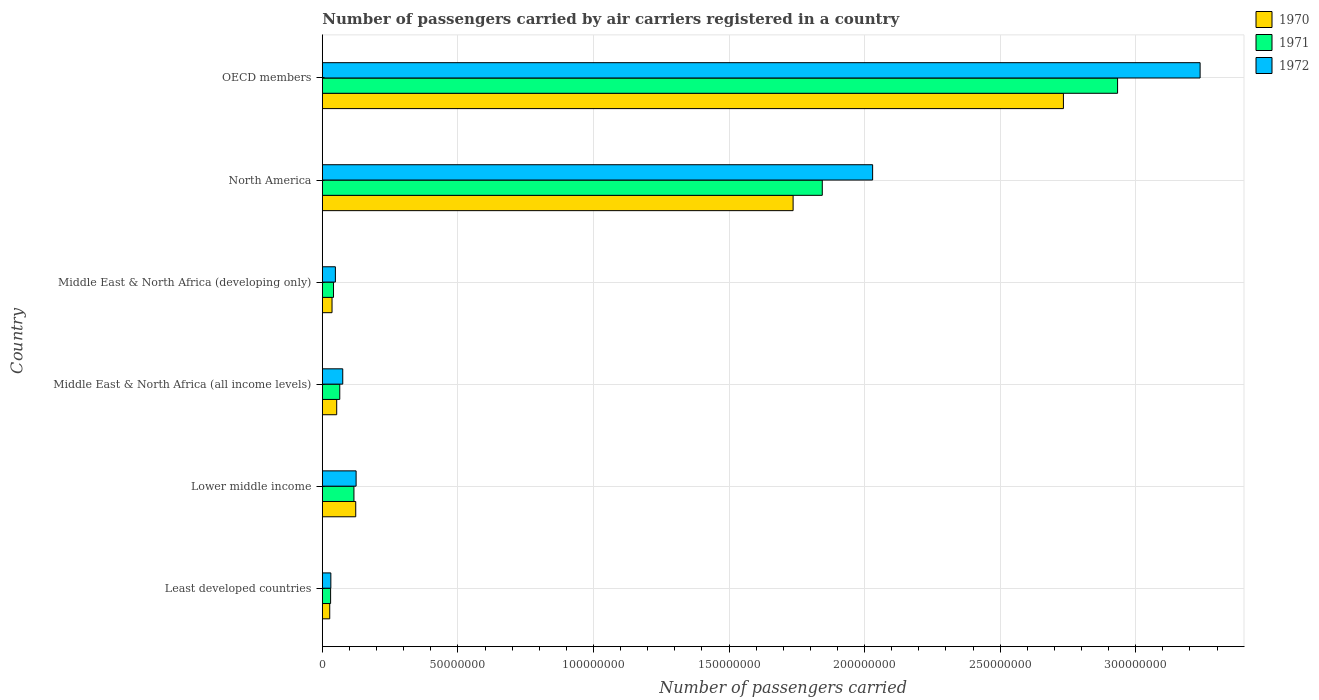How many different coloured bars are there?
Offer a very short reply. 3. Are the number of bars per tick equal to the number of legend labels?
Offer a terse response. Yes. What is the label of the 3rd group of bars from the top?
Make the answer very short. Middle East & North Africa (developing only). In how many cases, is the number of bars for a given country not equal to the number of legend labels?
Keep it short and to the point. 0. What is the number of passengers carried by air carriers in 1971 in Middle East & North Africa (all income levels)?
Your response must be concise. 6.43e+06. Across all countries, what is the maximum number of passengers carried by air carriers in 1971?
Provide a succinct answer. 2.93e+08. Across all countries, what is the minimum number of passengers carried by air carriers in 1970?
Your answer should be compact. 2.73e+06. In which country was the number of passengers carried by air carriers in 1972 minimum?
Your response must be concise. Least developed countries. What is the total number of passengers carried by air carriers in 1972 in the graph?
Your answer should be compact. 5.55e+08. What is the difference between the number of passengers carried by air carriers in 1970 in Middle East & North Africa (developing only) and that in North America?
Make the answer very short. -1.70e+08. What is the difference between the number of passengers carried by air carriers in 1972 in North America and the number of passengers carried by air carriers in 1970 in Middle East & North Africa (developing only)?
Provide a succinct answer. 1.99e+08. What is the average number of passengers carried by air carriers in 1970 per country?
Your answer should be very brief. 7.85e+07. What is the difference between the number of passengers carried by air carriers in 1971 and number of passengers carried by air carriers in 1972 in OECD members?
Your response must be concise. -3.04e+07. What is the ratio of the number of passengers carried by air carriers in 1971 in Middle East & North Africa (developing only) to that in North America?
Your response must be concise. 0.02. Is the difference between the number of passengers carried by air carriers in 1971 in Least developed countries and OECD members greater than the difference between the number of passengers carried by air carriers in 1972 in Least developed countries and OECD members?
Provide a succinct answer. Yes. What is the difference between the highest and the second highest number of passengers carried by air carriers in 1970?
Offer a very short reply. 9.97e+07. What is the difference between the highest and the lowest number of passengers carried by air carriers in 1972?
Give a very brief answer. 3.21e+08. In how many countries, is the number of passengers carried by air carriers in 1970 greater than the average number of passengers carried by air carriers in 1970 taken over all countries?
Provide a succinct answer. 2. What does the 2nd bar from the top in North America represents?
Offer a very short reply. 1971. What does the 1st bar from the bottom in OECD members represents?
Provide a short and direct response. 1970. Is it the case that in every country, the sum of the number of passengers carried by air carriers in 1972 and number of passengers carried by air carriers in 1970 is greater than the number of passengers carried by air carriers in 1971?
Make the answer very short. Yes. Are all the bars in the graph horizontal?
Your answer should be very brief. Yes. What is the difference between two consecutive major ticks on the X-axis?
Your answer should be very brief. 5.00e+07. Where does the legend appear in the graph?
Keep it short and to the point. Top right. How are the legend labels stacked?
Give a very brief answer. Vertical. What is the title of the graph?
Ensure brevity in your answer.  Number of passengers carried by air carriers registered in a country. Does "1986" appear as one of the legend labels in the graph?
Offer a very short reply. No. What is the label or title of the X-axis?
Your response must be concise. Number of passengers carried. What is the Number of passengers carried of 1970 in Least developed countries?
Make the answer very short. 2.73e+06. What is the Number of passengers carried in 1971 in Least developed countries?
Ensure brevity in your answer.  3.05e+06. What is the Number of passengers carried of 1972 in Least developed countries?
Provide a short and direct response. 3.14e+06. What is the Number of passengers carried in 1970 in Lower middle income?
Make the answer very short. 1.23e+07. What is the Number of passengers carried in 1971 in Lower middle income?
Your response must be concise. 1.17e+07. What is the Number of passengers carried in 1972 in Lower middle income?
Make the answer very short. 1.25e+07. What is the Number of passengers carried in 1970 in Middle East & North Africa (all income levels)?
Offer a very short reply. 5.30e+06. What is the Number of passengers carried of 1971 in Middle East & North Africa (all income levels)?
Your answer should be compact. 6.43e+06. What is the Number of passengers carried of 1972 in Middle East & North Africa (all income levels)?
Your answer should be compact. 7.53e+06. What is the Number of passengers carried in 1970 in Middle East & North Africa (developing only)?
Your answer should be very brief. 3.58e+06. What is the Number of passengers carried of 1971 in Middle East & North Africa (developing only)?
Offer a terse response. 4.12e+06. What is the Number of passengers carried in 1972 in Middle East & North Africa (developing only)?
Provide a succinct answer. 4.82e+06. What is the Number of passengers carried in 1970 in North America?
Provide a short and direct response. 1.74e+08. What is the Number of passengers carried in 1971 in North America?
Your answer should be compact. 1.84e+08. What is the Number of passengers carried in 1972 in North America?
Your answer should be compact. 2.03e+08. What is the Number of passengers carried of 1970 in OECD members?
Your answer should be very brief. 2.73e+08. What is the Number of passengers carried in 1971 in OECD members?
Ensure brevity in your answer.  2.93e+08. What is the Number of passengers carried in 1972 in OECD members?
Provide a succinct answer. 3.24e+08. Across all countries, what is the maximum Number of passengers carried of 1970?
Your response must be concise. 2.73e+08. Across all countries, what is the maximum Number of passengers carried in 1971?
Provide a short and direct response. 2.93e+08. Across all countries, what is the maximum Number of passengers carried in 1972?
Offer a terse response. 3.24e+08. Across all countries, what is the minimum Number of passengers carried of 1970?
Provide a short and direct response. 2.73e+06. Across all countries, what is the minimum Number of passengers carried in 1971?
Ensure brevity in your answer.  3.05e+06. Across all countries, what is the minimum Number of passengers carried of 1972?
Ensure brevity in your answer.  3.14e+06. What is the total Number of passengers carried of 1970 in the graph?
Provide a short and direct response. 4.71e+08. What is the total Number of passengers carried of 1971 in the graph?
Give a very brief answer. 5.03e+08. What is the total Number of passengers carried in 1972 in the graph?
Your response must be concise. 5.55e+08. What is the difference between the Number of passengers carried of 1970 in Least developed countries and that in Lower middle income?
Ensure brevity in your answer.  -9.59e+06. What is the difference between the Number of passengers carried in 1971 in Least developed countries and that in Lower middle income?
Your answer should be very brief. -8.60e+06. What is the difference between the Number of passengers carried of 1972 in Least developed countries and that in Lower middle income?
Provide a succinct answer. -9.32e+06. What is the difference between the Number of passengers carried in 1970 in Least developed countries and that in Middle East & North Africa (all income levels)?
Provide a short and direct response. -2.57e+06. What is the difference between the Number of passengers carried of 1971 in Least developed countries and that in Middle East & North Africa (all income levels)?
Give a very brief answer. -3.37e+06. What is the difference between the Number of passengers carried in 1972 in Least developed countries and that in Middle East & North Africa (all income levels)?
Ensure brevity in your answer.  -4.39e+06. What is the difference between the Number of passengers carried of 1970 in Least developed countries and that in Middle East & North Africa (developing only)?
Offer a very short reply. -8.45e+05. What is the difference between the Number of passengers carried of 1971 in Least developed countries and that in Middle East & North Africa (developing only)?
Give a very brief answer. -1.07e+06. What is the difference between the Number of passengers carried of 1972 in Least developed countries and that in Middle East & North Africa (developing only)?
Provide a succinct answer. -1.68e+06. What is the difference between the Number of passengers carried in 1970 in Least developed countries and that in North America?
Keep it short and to the point. -1.71e+08. What is the difference between the Number of passengers carried of 1971 in Least developed countries and that in North America?
Your answer should be compact. -1.81e+08. What is the difference between the Number of passengers carried in 1972 in Least developed countries and that in North America?
Provide a short and direct response. -2.00e+08. What is the difference between the Number of passengers carried in 1970 in Least developed countries and that in OECD members?
Make the answer very short. -2.71e+08. What is the difference between the Number of passengers carried in 1971 in Least developed countries and that in OECD members?
Make the answer very short. -2.90e+08. What is the difference between the Number of passengers carried in 1972 in Least developed countries and that in OECD members?
Your answer should be compact. -3.21e+08. What is the difference between the Number of passengers carried of 1970 in Lower middle income and that in Middle East & North Africa (all income levels)?
Ensure brevity in your answer.  7.02e+06. What is the difference between the Number of passengers carried of 1971 in Lower middle income and that in Middle East & North Africa (all income levels)?
Your answer should be very brief. 5.23e+06. What is the difference between the Number of passengers carried in 1972 in Lower middle income and that in Middle East & North Africa (all income levels)?
Give a very brief answer. 4.93e+06. What is the difference between the Number of passengers carried of 1970 in Lower middle income and that in Middle East & North Africa (developing only)?
Make the answer very short. 8.74e+06. What is the difference between the Number of passengers carried in 1971 in Lower middle income and that in Middle East & North Africa (developing only)?
Keep it short and to the point. 7.53e+06. What is the difference between the Number of passengers carried in 1972 in Lower middle income and that in Middle East & North Africa (developing only)?
Your response must be concise. 7.64e+06. What is the difference between the Number of passengers carried of 1970 in Lower middle income and that in North America?
Provide a succinct answer. -1.61e+08. What is the difference between the Number of passengers carried of 1971 in Lower middle income and that in North America?
Ensure brevity in your answer.  -1.73e+08. What is the difference between the Number of passengers carried of 1972 in Lower middle income and that in North America?
Offer a terse response. -1.90e+08. What is the difference between the Number of passengers carried of 1970 in Lower middle income and that in OECD members?
Ensure brevity in your answer.  -2.61e+08. What is the difference between the Number of passengers carried in 1971 in Lower middle income and that in OECD members?
Provide a short and direct response. -2.82e+08. What is the difference between the Number of passengers carried in 1972 in Lower middle income and that in OECD members?
Give a very brief answer. -3.11e+08. What is the difference between the Number of passengers carried of 1970 in Middle East & North Africa (all income levels) and that in Middle East & North Africa (developing only)?
Ensure brevity in your answer.  1.73e+06. What is the difference between the Number of passengers carried of 1971 in Middle East & North Africa (all income levels) and that in Middle East & North Africa (developing only)?
Make the answer very short. 2.30e+06. What is the difference between the Number of passengers carried of 1972 in Middle East & North Africa (all income levels) and that in Middle East & North Africa (developing only)?
Keep it short and to the point. 2.71e+06. What is the difference between the Number of passengers carried of 1970 in Middle East & North Africa (all income levels) and that in North America?
Make the answer very short. -1.68e+08. What is the difference between the Number of passengers carried in 1971 in Middle East & North Africa (all income levels) and that in North America?
Offer a very short reply. -1.78e+08. What is the difference between the Number of passengers carried in 1972 in Middle East & North Africa (all income levels) and that in North America?
Give a very brief answer. -1.95e+08. What is the difference between the Number of passengers carried of 1970 in Middle East & North Africa (all income levels) and that in OECD members?
Your answer should be compact. -2.68e+08. What is the difference between the Number of passengers carried in 1971 in Middle East & North Africa (all income levels) and that in OECD members?
Provide a succinct answer. -2.87e+08. What is the difference between the Number of passengers carried in 1972 in Middle East & North Africa (all income levels) and that in OECD members?
Your answer should be very brief. -3.16e+08. What is the difference between the Number of passengers carried in 1970 in Middle East & North Africa (developing only) and that in North America?
Keep it short and to the point. -1.70e+08. What is the difference between the Number of passengers carried in 1971 in Middle East & North Africa (developing only) and that in North America?
Your answer should be compact. -1.80e+08. What is the difference between the Number of passengers carried in 1972 in Middle East & North Africa (developing only) and that in North America?
Your answer should be very brief. -1.98e+08. What is the difference between the Number of passengers carried of 1970 in Middle East & North Africa (developing only) and that in OECD members?
Ensure brevity in your answer.  -2.70e+08. What is the difference between the Number of passengers carried in 1971 in Middle East & North Africa (developing only) and that in OECD members?
Give a very brief answer. -2.89e+08. What is the difference between the Number of passengers carried in 1972 in Middle East & North Africa (developing only) and that in OECD members?
Ensure brevity in your answer.  -3.19e+08. What is the difference between the Number of passengers carried of 1970 in North America and that in OECD members?
Make the answer very short. -9.97e+07. What is the difference between the Number of passengers carried in 1971 in North America and that in OECD members?
Ensure brevity in your answer.  -1.09e+08. What is the difference between the Number of passengers carried in 1972 in North America and that in OECD members?
Make the answer very short. -1.21e+08. What is the difference between the Number of passengers carried of 1970 in Least developed countries and the Number of passengers carried of 1971 in Lower middle income?
Your answer should be compact. -8.93e+06. What is the difference between the Number of passengers carried in 1970 in Least developed countries and the Number of passengers carried in 1972 in Lower middle income?
Offer a very short reply. -9.73e+06. What is the difference between the Number of passengers carried of 1971 in Least developed countries and the Number of passengers carried of 1972 in Lower middle income?
Your answer should be compact. -9.41e+06. What is the difference between the Number of passengers carried in 1970 in Least developed countries and the Number of passengers carried in 1971 in Middle East & North Africa (all income levels)?
Your response must be concise. -3.70e+06. What is the difference between the Number of passengers carried of 1970 in Least developed countries and the Number of passengers carried of 1972 in Middle East & North Africa (all income levels)?
Provide a succinct answer. -4.80e+06. What is the difference between the Number of passengers carried of 1971 in Least developed countries and the Number of passengers carried of 1972 in Middle East & North Africa (all income levels)?
Your response must be concise. -4.47e+06. What is the difference between the Number of passengers carried of 1970 in Least developed countries and the Number of passengers carried of 1971 in Middle East & North Africa (developing only)?
Offer a terse response. -1.39e+06. What is the difference between the Number of passengers carried of 1970 in Least developed countries and the Number of passengers carried of 1972 in Middle East & North Africa (developing only)?
Offer a very short reply. -2.09e+06. What is the difference between the Number of passengers carried in 1971 in Least developed countries and the Number of passengers carried in 1972 in Middle East & North Africa (developing only)?
Provide a succinct answer. -1.76e+06. What is the difference between the Number of passengers carried of 1970 in Least developed countries and the Number of passengers carried of 1971 in North America?
Offer a terse response. -1.82e+08. What is the difference between the Number of passengers carried in 1970 in Least developed countries and the Number of passengers carried in 1972 in North America?
Your answer should be very brief. -2.00e+08. What is the difference between the Number of passengers carried of 1971 in Least developed countries and the Number of passengers carried of 1972 in North America?
Your response must be concise. -2.00e+08. What is the difference between the Number of passengers carried in 1970 in Least developed countries and the Number of passengers carried in 1971 in OECD members?
Offer a terse response. -2.91e+08. What is the difference between the Number of passengers carried in 1970 in Least developed countries and the Number of passengers carried in 1972 in OECD members?
Your response must be concise. -3.21e+08. What is the difference between the Number of passengers carried in 1971 in Least developed countries and the Number of passengers carried in 1972 in OECD members?
Ensure brevity in your answer.  -3.21e+08. What is the difference between the Number of passengers carried in 1970 in Lower middle income and the Number of passengers carried in 1971 in Middle East & North Africa (all income levels)?
Your response must be concise. 5.89e+06. What is the difference between the Number of passengers carried of 1970 in Lower middle income and the Number of passengers carried of 1972 in Middle East & North Africa (all income levels)?
Your response must be concise. 4.79e+06. What is the difference between the Number of passengers carried of 1971 in Lower middle income and the Number of passengers carried of 1972 in Middle East & North Africa (all income levels)?
Offer a very short reply. 4.13e+06. What is the difference between the Number of passengers carried of 1970 in Lower middle income and the Number of passengers carried of 1971 in Middle East & North Africa (developing only)?
Your answer should be very brief. 8.20e+06. What is the difference between the Number of passengers carried in 1970 in Lower middle income and the Number of passengers carried in 1972 in Middle East & North Africa (developing only)?
Provide a succinct answer. 7.50e+06. What is the difference between the Number of passengers carried in 1971 in Lower middle income and the Number of passengers carried in 1972 in Middle East & North Africa (developing only)?
Offer a terse response. 6.84e+06. What is the difference between the Number of passengers carried of 1970 in Lower middle income and the Number of passengers carried of 1971 in North America?
Give a very brief answer. -1.72e+08. What is the difference between the Number of passengers carried of 1970 in Lower middle income and the Number of passengers carried of 1972 in North America?
Your answer should be very brief. -1.91e+08. What is the difference between the Number of passengers carried in 1971 in Lower middle income and the Number of passengers carried in 1972 in North America?
Give a very brief answer. -1.91e+08. What is the difference between the Number of passengers carried of 1970 in Lower middle income and the Number of passengers carried of 1971 in OECD members?
Ensure brevity in your answer.  -2.81e+08. What is the difference between the Number of passengers carried in 1970 in Lower middle income and the Number of passengers carried in 1972 in OECD members?
Your response must be concise. -3.11e+08. What is the difference between the Number of passengers carried in 1971 in Lower middle income and the Number of passengers carried in 1972 in OECD members?
Provide a short and direct response. -3.12e+08. What is the difference between the Number of passengers carried in 1970 in Middle East & North Africa (all income levels) and the Number of passengers carried in 1971 in Middle East & North Africa (developing only)?
Your answer should be compact. 1.18e+06. What is the difference between the Number of passengers carried of 1970 in Middle East & North Africa (all income levels) and the Number of passengers carried of 1972 in Middle East & North Africa (developing only)?
Your answer should be compact. 4.86e+05. What is the difference between the Number of passengers carried of 1971 in Middle East & North Africa (all income levels) and the Number of passengers carried of 1972 in Middle East & North Africa (developing only)?
Offer a very short reply. 1.61e+06. What is the difference between the Number of passengers carried of 1970 in Middle East & North Africa (all income levels) and the Number of passengers carried of 1971 in North America?
Keep it short and to the point. -1.79e+08. What is the difference between the Number of passengers carried of 1970 in Middle East & North Africa (all income levels) and the Number of passengers carried of 1972 in North America?
Your answer should be compact. -1.98e+08. What is the difference between the Number of passengers carried in 1971 in Middle East & North Africa (all income levels) and the Number of passengers carried in 1972 in North America?
Provide a short and direct response. -1.97e+08. What is the difference between the Number of passengers carried of 1970 in Middle East & North Africa (all income levels) and the Number of passengers carried of 1971 in OECD members?
Your answer should be very brief. -2.88e+08. What is the difference between the Number of passengers carried in 1970 in Middle East & North Africa (all income levels) and the Number of passengers carried in 1972 in OECD members?
Ensure brevity in your answer.  -3.18e+08. What is the difference between the Number of passengers carried in 1971 in Middle East & North Africa (all income levels) and the Number of passengers carried in 1972 in OECD members?
Provide a succinct answer. -3.17e+08. What is the difference between the Number of passengers carried of 1970 in Middle East & North Africa (developing only) and the Number of passengers carried of 1971 in North America?
Your response must be concise. -1.81e+08. What is the difference between the Number of passengers carried in 1970 in Middle East & North Africa (developing only) and the Number of passengers carried in 1972 in North America?
Your response must be concise. -1.99e+08. What is the difference between the Number of passengers carried in 1971 in Middle East & North Africa (developing only) and the Number of passengers carried in 1972 in North America?
Ensure brevity in your answer.  -1.99e+08. What is the difference between the Number of passengers carried in 1970 in Middle East & North Africa (developing only) and the Number of passengers carried in 1971 in OECD members?
Your response must be concise. -2.90e+08. What is the difference between the Number of passengers carried in 1970 in Middle East & North Africa (developing only) and the Number of passengers carried in 1972 in OECD members?
Your response must be concise. -3.20e+08. What is the difference between the Number of passengers carried in 1971 in Middle East & North Africa (developing only) and the Number of passengers carried in 1972 in OECD members?
Ensure brevity in your answer.  -3.20e+08. What is the difference between the Number of passengers carried of 1970 in North America and the Number of passengers carried of 1971 in OECD members?
Ensure brevity in your answer.  -1.20e+08. What is the difference between the Number of passengers carried in 1970 in North America and the Number of passengers carried in 1972 in OECD members?
Provide a succinct answer. -1.50e+08. What is the difference between the Number of passengers carried in 1971 in North America and the Number of passengers carried in 1972 in OECD members?
Your answer should be very brief. -1.39e+08. What is the average Number of passengers carried in 1970 per country?
Make the answer very short. 7.85e+07. What is the average Number of passengers carried in 1971 per country?
Keep it short and to the point. 8.38e+07. What is the average Number of passengers carried of 1972 per country?
Provide a succinct answer. 9.24e+07. What is the difference between the Number of passengers carried of 1970 and Number of passengers carried of 1971 in Least developed countries?
Your answer should be compact. -3.23e+05. What is the difference between the Number of passengers carried of 1970 and Number of passengers carried of 1972 in Least developed countries?
Your answer should be very brief. -4.07e+05. What is the difference between the Number of passengers carried of 1971 and Number of passengers carried of 1972 in Least developed countries?
Your answer should be compact. -8.41e+04. What is the difference between the Number of passengers carried of 1970 and Number of passengers carried of 1971 in Lower middle income?
Your response must be concise. 6.64e+05. What is the difference between the Number of passengers carried in 1970 and Number of passengers carried in 1972 in Lower middle income?
Your answer should be compact. -1.41e+05. What is the difference between the Number of passengers carried in 1971 and Number of passengers carried in 1972 in Lower middle income?
Provide a short and direct response. -8.05e+05. What is the difference between the Number of passengers carried of 1970 and Number of passengers carried of 1971 in Middle East & North Africa (all income levels)?
Your response must be concise. -1.13e+06. What is the difference between the Number of passengers carried in 1970 and Number of passengers carried in 1972 in Middle East & North Africa (all income levels)?
Ensure brevity in your answer.  -2.23e+06. What is the difference between the Number of passengers carried of 1971 and Number of passengers carried of 1972 in Middle East & North Africa (all income levels)?
Provide a succinct answer. -1.10e+06. What is the difference between the Number of passengers carried of 1970 and Number of passengers carried of 1971 in Middle East & North Africa (developing only)?
Give a very brief answer. -5.49e+05. What is the difference between the Number of passengers carried of 1970 and Number of passengers carried of 1972 in Middle East & North Africa (developing only)?
Make the answer very short. -1.24e+06. What is the difference between the Number of passengers carried in 1971 and Number of passengers carried in 1972 in Middle East & North Africa (developing only)?
Your answer should be very brief. -6.92e+05. What is the difference between the Number of passengers carried of 1970 and Number of passengers carried of 1971 in North America?
Provide a succinct answer. -1.08e+07. What is the difference between the Number of passengers carried of 1970 and Number of passengers carried of 1972 in North America?
Keep it short and to the point. -2.93e+07. What is the difference between the Number of passengers carried of 1971 and Number of passengers carried of 1972 in North America?
Give a very brief answer. -1.86e+07. What is the difference between the Number of passengers carried in 1970 and Number of passengers carried in 1971 in OECD members?
Your response must be concise. -2.00e+07. What is the difference between the Number of passengers carried of 1970 and Number of passengers carried of 1972 in OECD members?
Ensure brevity in your answer.  -5.04e+07. What is the difference between the Number of passengers carried in 1971 and Number of passengers carried in 1972 in OECD members?
Ensure brevity in your answer.  -3.04e+07. What is the ratio of the Number of passengers carried in 1970 in Least developed countries to that in Lower middle income?
Your answer should be very brief. 0.22. What is the ratio of the Number of passengers carried of 1971 in Least developed countries to that in Lower middle income?
Your answer should be very brief. 0.26. What is the ratio of the Number of passengers carried in 1972 in Least developed countries to that in Lower middle income?
Keep it short and to the point. 0.25. What is the ratio of the Number of passengers carried in 1970 in Least developed countries to that in Middle East & North Africa (all income levels)?
Your answer should be compact. 0.52. What is the ratio of the Number of passengers carried in 1971 in Least developed countries to that in Middle East & North Africa (all income levels)?
Give a very brief answer. 0.47. What is the ratio of the Number of passengers carried in 1972 in Least developed countries to that in Middle East & North Africa (all income levels)?
Make the answer very short. 0.42. What is the ratio of the Number of passengers carried in 1970 in Least developed countries to that in Middle East & North Africa (developing only)?
Ensure brevity in your answer.  0.76. What is the ratio of the Number of passengers carried in 1971 in Least developed countries to that in Middle East & North Africa (developing only)?
Ensure brevity in your answer.  0.74. What is the ratio of the Number of passengers carried of 1972 in Least developed countries to that in Middle East & North Africa (developing only)?
Keep it short and to the point. 0.65. What is the ratio of the Number of passengers carried of 1970 in Least developed countries to that in North America?
Your answer should be compact. 0.02. What is the ratio of the Number of passengers carried in 1971 in Least developed countries to that in North America?
Ensure brevity in your answer.  0.02. What is the ratio of the Number of passengers carried of 1972 in Least developed countries to that in North America?
Keep it short and to the point. 0.02. What is the ratio of the Number of passengers carried in 1970 in Least developed countries to that in OECD members?
Your response must be concise. 0.01. What is the ratio of the Number of passengers carried of 1971 in Least developed countries to that in OECD members?
Make the answer very short. 0.01. What is the ratio of the Number of passengers carried of 1972 in Least developed countries to that in OECD members?
Offer a very short reply. 0.01. What is the ratio of the Number of passengers carried in 1970 in Lower middle income to that in Middle East & North Africa (all income levels)?
Give a very brief answer. 2.32. What is the ratio of the Number of passengers carried of 1971 in Lower middle income to that in Middle East & North Africa (all income levels)?
Ensure brevity in your answer.  1.81. What is the ratio of the Number of passengers carried of 1972 in Lower middle income to that in Middle East & North Africa (all income levels)?
Provide a succinct answer. 1.66. What is the ratio of the Number of passengers carried in 1970 in Lower middle income to that in Middle East & North Africa (developing only)?
Provide a succinct answer. 3.45. What is the ratio of the Number of passengers carried of 1971 in Lower middle income to that in Middle East & North Africa (developing only)?
Offer a very short reply. 2.83. What is the ratio of the Number of passengers carried of 1972 in Lower middle income to that in Middle East & North Africa (developing only)?
Your answer should be very brief. 2.59. What is the ratio of the Number of passengers carried in 1970 in Lower middle income to that in North America?
Your answer should be compact. 0.07. What is the ratio of the Number of passengers carried in 1971 in Lower middle income to that in North America?
Your response must be concise. 0.06. What is the ratio of the Number of passengers carried in 1972 in Lower middle income to that in North America?
Make the answer very short. 0.06. What is the ratio of the Number of passengers carried in 1970 in Lower middle income to that in OECD members?
Give a very brief answer. 0.05. What is the ratio of the Number of passengers carried in 1971 in Lower middle income to that in OECD members?
Provide a succinct answer. 0.04. What is the ratio of the Number of passengers carried in 1972 in Lower middle income to that in OECD members?
Offer a very short reply. 0.04. What is the ratio of the Number of passengers carried of 1970 in Middle East & North Africa (all income levels) to that in Middle East & North Africa (developing only)?
Provide a short and direct response. 1.48. What is the ratio of the Number of passengers carried of 1971 in Middle East & North Africa (all income levels) to that in Middle East & North Africa (developing only)?
Your answer should be compact. 1.56. What is the ratio of the Number of passengers carried in 1972 in Middle East & North Africa (all income levels) to that in Middle East & North Africa (developing only)?
Provide a short and direct response. 1.56. What is the ratio of the Number of passengers carried in 1970 in Middle East & North Africa (all income levels) to that in North America?
Offer a terse response. 0.03. What is the ratio of the Number of passengers carried of 1971 in Middle East & North Africa (all income levels) to that in North America?
Provide a succinct answer. 0.03. What is the ratio of the Number of passengers carried in 1972 in Middle East & North Africa (all income levels) to that in North America?
Your answer should be compact. 0.04. What is the ratio of the Number of passengers carried of 1970 in Middle East & North Africa (all income levels) to that in OECD members?
Offer a terse response. 0.02. What is the ratio of the Number of passengers carried in 1971 in Middle East & North Africa (all income levels) to that in OECD members?
Provide a succinct answer. 0.02. What is the ratio of the Number of passengers carried of 1972 in Middle East & North Africa (all income levels) to that in OECD members?
Your response must be concise. 0.02. What is the ratio of the Number of passengers carried of 1970 in Middle East & North Africa (developing only) to that in North America?
Your answer should be compact. 0.02. What is the ratio of the Number of passengers carried of 1971 in Middle East & North Africa (developing only) to that in North America?
Your answer should be compact. 0.02. What is the ratio of the Number of passengers carried of 1972 in Middle East & North Africa (developing only) to that in North America?
Offer a very short reply. 0.02. What is the ratio of the Number of passengers carried in 1970 in Middle East & North Africa (developing only) to that in OECD members?
Keep it short and to the point. 0.01. What is the ratio of the Number of passengers carried in 1971 in Middle East & North Africa (developing only) to that in OECD members?
Keep it short and to the point. 0.01. What is the ratio of the Number of passengers carried of 1972 in Middle East & North Africa (developing only) to that in OECD members?
Provide a succinct answer. 0.01. What is the ratio of the Number of passengers carried in 1970 in North America to that in OECD members?
Offer a very short reply. 0.64. What is the ratio of the Number of passengers carried of 1971 in North America to that in OECD members?
Provide a succinct answer. 0.63. What is the ratio of the Number of passengers carried of 1972 in North America to that in OECD members?
Provide a short and direct response. 0.63. What is the difference between the highest and the second highest Number of passengers carried in 1970?
Give a very brief answer. 9.97e+07. What is the difference between the highest and the second highest Number of passengers carried in 1971?
Keep it short and to the point. 1.09e+08. What is the difference between the highest and the second highest Number of passengers carried in 1972?
Provide a succinct answer. 1.21e+08. What is the difference between the highest and the lowest Number of passengers carried of 1970?
Ensure brevity in your answer.  2.71e+08. What is the difference between the highest and the lowest Number of passengers carried of 1971?
Give a very brief answer. 2.90e+08. What is the difference between the highest and the lowest Number of passengers carried in 1972?
Your answer should be compact. 3.21e+08. 